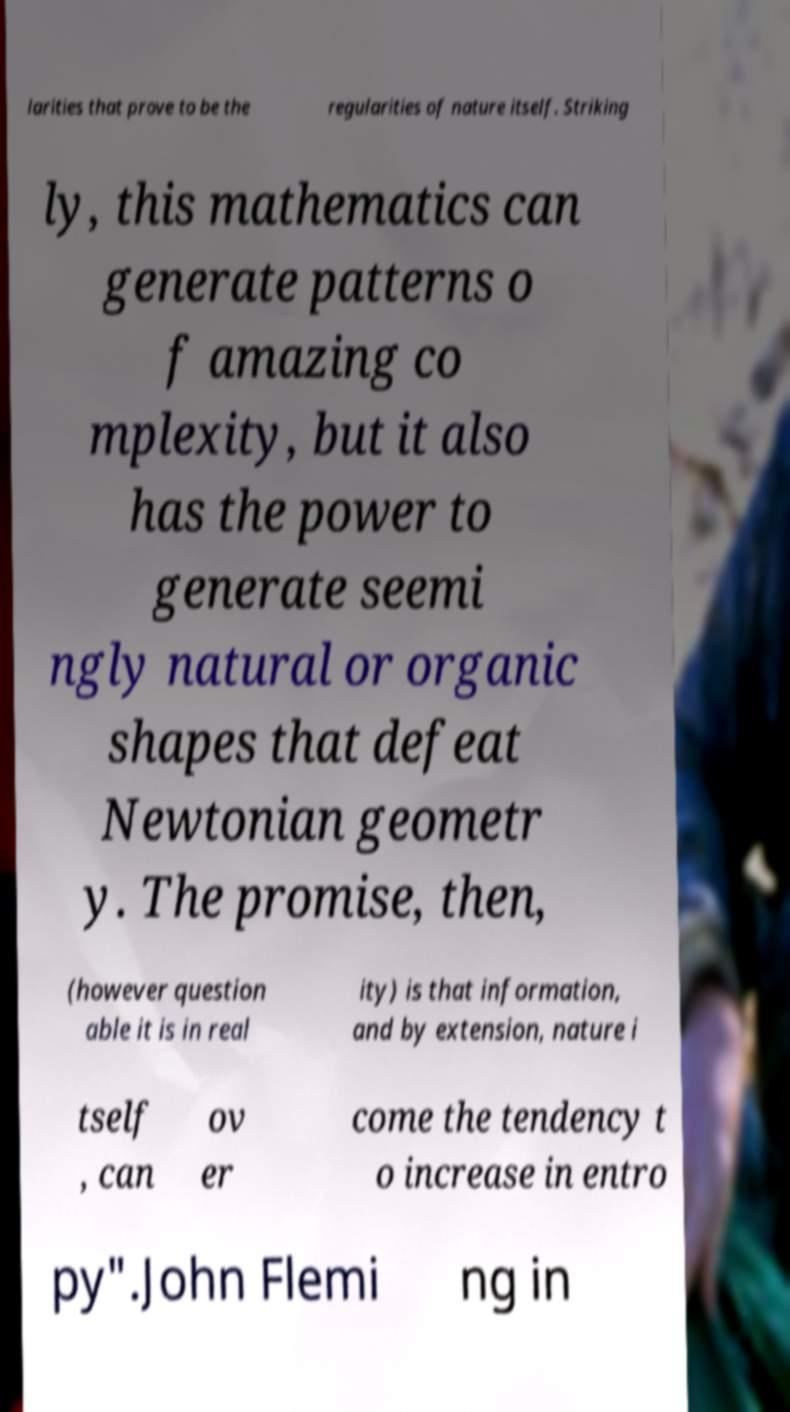What messages or text are displayed in this image? I need them in a readable, typed format. larities that prove to be the regularities of nature itself. Striking ly, this mathematics can generate patterns o f amazing co mplexity, but it also has the power to generate seemi ngly natural or organic shapes that defeat Newtonian geometr y. The promise, then, (however question able it is in real ity) is that information, and by extension, nature i tself , can ov er come the tendency t o increase in entro py".John Flemi ng in 